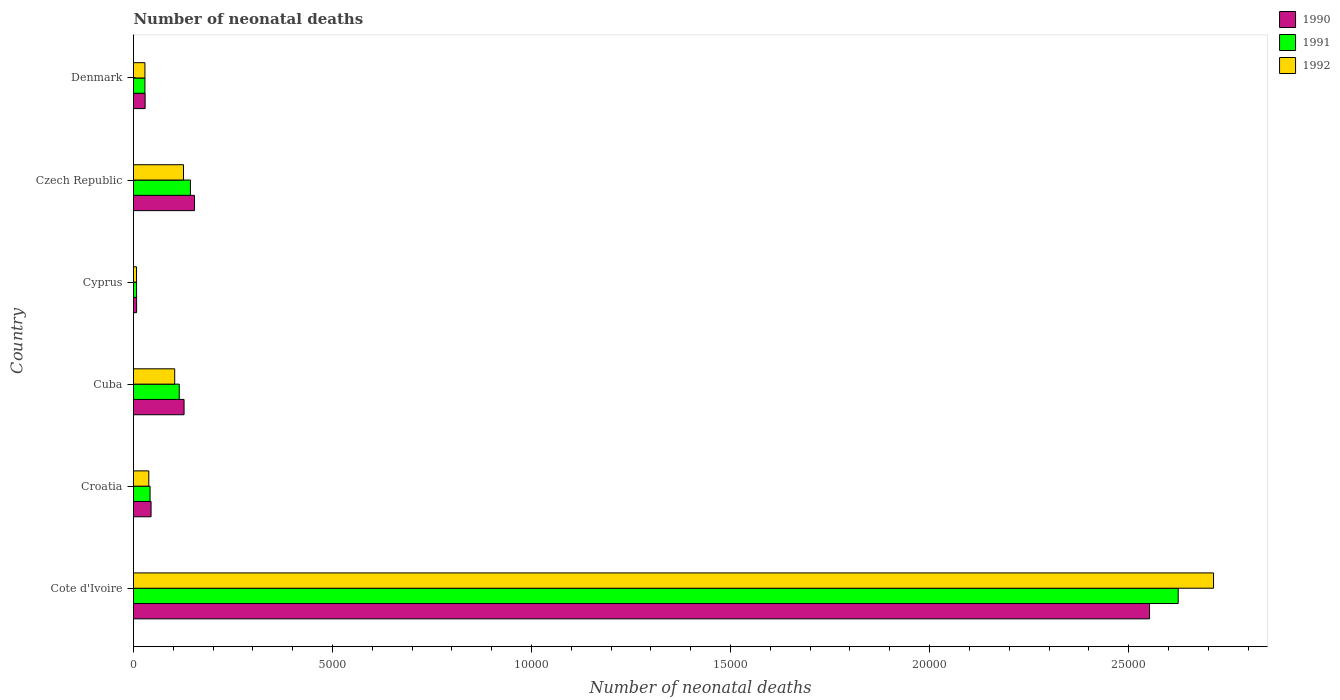How many different coloured bars are there?
Your answer should be very brief. 3. How many groups of bars are there?
Offer a very short reply. 6. How many bars are there on the 6th tick from the top?
Your answer should be very brief. 3. What is the label of the 6th group of bars from the top?
Provide a succinct answer. Cote d'Ivoire. In how many cases, is the number of bars for a given country not equal to the number of legend labels?
Ensure brevity in your answer.  0. What is the number of neonatal deaths in in 1990 in Croatia?
Give a very brief answer. 441. Across all countries, what is the maximum number of neonatal deaths in in 1990?
Make the answer very short. 2.55e+04. Across all countries, what is the minimum number of neonatal deaths in in 1992?
Keep it short and to the point. 76. In which country was the number of neonatal deaths in in 1990 maximum?
Offer a terse response. Cote d'Ivoire. In which country was the number of neonatal deaths in in 1990 minimum?
Provide a succinct answer. Cyprus. What is the total number of neonatal deaths in in 1991 in the graph?
Provide a short and direct response. 2.96e+04. What is the difference between the number of neonatal deaths in in 1991 in Cote d'Ivoire and that in Croatia?
Make the answer very short. 2.58e+04. What is the difference between the number of neonatal deaths in in 1990 in Denmark and the number of neonatal deaths in in 1991 in Czech Republic?
Ensure brevity in your answer.  -1138. What is the average number of neonatal deaths in in 1990 per country?
Your answer should be compact. 4856.67. What is the difference between the number of neonatal deaths in in 1992 and number of neonatal deaths in in 1991 in Cote d'Ivoire?
Your response must be concise. 888. In how many countries, is the number of neonatal deaths in in 1992 greater than 25000 ?
Your answer should be compact. 1. What is the ratio of the number of neonatal deaths in in 1990 in Cote d'Ivoire to that in Czech Republic?
Keep it short and to the point. 16.65. Is the difference between the number of neonatal deaths in in 1992 in Cote d'Ivoire and Cyprus greater than the difference between the number of neonatal deaths in in 1991 in Cote d'Ivoire and Cyprus?
Ensure brevity in your answer.  Yes. What is the difference between the highest and the second highest number of neonatal deaths in in 1992?
Give a very brief answer. 2.59e+04. What is the difference between the highest and the lowest number of neonatal deaths in in 1991?
Your response must be concise. 2.62e+04. In how many countries, is the number of neonatal deaths in in 1990 greater than the average number of neonatal deaths in in 1990 taken over all countries?
Provide a succinct answer. 1. Is the sum of the number of neonatal deaths in in 1990 in Croatia and Denmark greater than the maximum number of neonatal deaths in in 1992 across all countries?
Provide a succinct answer. No. How many bars are there?
Give a very brief answer. 18. How many countries are there in the graph?
Offer a terse response. 6. Where does the legend appear in the graph?
Your answer should be very brief. Top right. How many legend labels are there?
Provide a succinct answer. 3. What is the title of the graph?
Offer a very short reply. Number of neonatal deaths. What is the label or title of the X-axis?
Your response must be concise. Number of neonatal deaths. What is the Number of neonatal deaths of 1990 in Cote d'Ivoire?
Provide a short and direct response. 2.55e+04. What is the Number of neonatal deaths of 1991 in Cote d'Ivoire?
Give a very brief answer. 2.62e+04. What is the Number of neonatal deaths in 1992 in Cote d'Ivoire?
Your answer should be very brief. 2.71e+04. What is the Number of neonatal deaths of 1990 in Croatia?
Offer a terse response. 441. What is the Number of neonatal deaths of 1991 in Croatia?
Ensure brevity in your answer.  416. What is the Number of neonatal deaths in 1992 in Croatia?
Keep it short and to the point. 384. What is the Number of neonatal deaths in 1990 in Cuba?
Keep it short and to the point. 1270. What is the Number of neonatal deaths in 1991 in Cuba?
Make the answer very short. 1149. What is the Number of neonatal deaths of 1992 in Cuba?
Make the answer very short. 1035. What is the Number of neonatal deaths in 1992 in Cyprus?
Your answer should be very brief. 76. What is the Number of neonatal deaths in 1990 in Czech Republic?
Give a very brief answer. 1533. What is the Number of neonatal deaths of 1991 in Czech Republic?
Make the answer very short. 1430. What is the Number of neonatal deaths of 1992 in Czech Republic?
Provide a succinct answer. 1256. What is the Number of neonatal deaths in 1990 in Denmark?
Your response must be concise. 292. What is the Number of neonatal deaths in 1991 in Denmark?
Ensure brevity in your answer.  287. What is the Number of neonatal deaths in 1992 in Denmark?
Make the answer very short. 287. Across all countries, what is the maximum Number of neonatal deaths of 1990?
Your response must be concise. 2.55e+04. Across all countries, what is the maximum Number of neonatal deaths of 1991?
Your answer should be very brief. 2.62e+04. Across all countries, what is the maximum Number of neonatal deaths of 1992?
Provide a short and direct response. 2.71e+04. Across all countries, what is the minimum Number of neonatal deaths of 1991?
Keep it short and to the point. 77. What is the total Number of neonatal deaths in 1990 in the graph?
Offer a terse response. 2.91e+04. What is the total Number of neonatal deaths of 1991 in the graph?
Provide a short and direct response. 2.96e+04. What is the total Number of neonatal deaths in 1992 in the graph?
Your answer should be very brief. 3.02e+04. What is the difference between the Number of neonatal deaths of 1990 in Cote d'Ivoire and that in Croatia?
Keep it short and to the point. 2.51e+04. What is the difference between the Number of neonatal deaths of 1991 in Cote d'Ivoire and that in Croatia?
Your response must be concise. 2.58e+04. What is the difference between the Number of neonatal deaths of 1992 in Cote d'Ivoire and that in Croatia?
Ensure brevity in your answer.  2.68e+04. What is the difference between the Number of neonatal deaths in 1990 in Cote d'Ivoire and that in Cuba?
Keep it short and to the point. 2.43e+04. What is the difference between the Number of neonatal deaths in 1991 in Cote d'Ivoire and that in Cuba?
Make the answer very short. 2.51e+04. What is the difference between the Number of neonatal deaths in 1992 in Cote d'Ivoire and that in Cuba?
Ensure brevity in your answer.  2.61e+04. What is the difference between the Number of neonatal deaths in 1990 in Cote d'Ivoire and that in Cyprus?
Provide a short and direct response. 2.54e+04. What is the difference between the Number of neonatal deaths in 1991 in Cote d'Ivoire and that in Cyprus?
Keep it short and to the point. 2.62e+04. What is the difference between the Number of neonatal deaths of 1992 in Cote d'Ivoire and that in Cyprus?
Offer a very short reply. 2.71e+04. What is the difference between the Number of neonatal deaths of 1990 in Cote d'Ivoire and that in Czech Republic?
Ensure brevity in your answer.  2.40e+04. What is the difference between the Number of neonatal deaths of 1991 in Cote d'Ivoire and that in Czech Republic?
Give a very brief answer. 2.48e+04. What is the difference between the Number of neonatal deaths of 1992 in Cote d'Ivoire and that in Czech Republic?
Provide a short and direct response. 2.59e+04. What is the difference between the Number of neonatal deaths of 1990 in Cote d'Ivoire and that in Denmark?
Make the answer very short. 2.52e+04. What is the difference between the Number of neonatal deaths in 1991 in Cote d'Ivoire and that in Denmark?
Keep it short and to the point. 2.60e+04. What is the difference between the Number of neonatal deaths in 1992 in Cote d'Ivoire and that in Denmark?
Offer a terse response. 2.68e+04. What is the difference between the Number of neonatal deaths in 1990 in Croatia and that in Cuba?
Keep it short and to the point. -829. What is the difference between the Number of neonatal deaths of 1991 in Croatia and that in Cuba?
Keep it short and to the point. -733. What is the difference between the Number of neonatal deaths in 1992 in Croatia and that in Cuba?
Offer a terse response. -651. What is the difference between the Number of neonatal deaths of 1990 in Croatia and that in Cyprus?
Provide a short and direct response. 363. What is the difference between the Number of neonatal deaths of 1991 in Croatia and that in Cyprus?
Your response must be concise. 339. What is the difference between the Number of neonatal deaths in 1992 in Croatia and that in Cyprus?
Your answer should be very brief. 308. What is the difference between the Number of neonatal deaths in 1990 in Croatia and that in Czech Republic?
Ensure brevity in your answer.  -1092. What is the difference between the Number of neonatal deaths in 1991 in Croatia and that in Czech Republic?
Provide a short and direct response. -1014. What is the difference between the Number of neonatal deaths in 1992 in Croatia and that in Czech Republic?
Give a very brief answer. -872. What is the difference between the Number of neonatal deaths in 1990 in Croatia and that in Denmark?
Offer a very short reply. 149. What is the difference between the Number of neonatal deaths of 1991 in Croatia and that in Denmark?
Provide a short and direct response. 129. What is the difference between the Number of neonatal deaths of 1992 in Croatia and that in Denmark?
Offer a very short reply. 97. What is the difference between the Number of neonatal deaths in 1990 in Cuba and that in Cyprus?
Your answer should be very brief. 1192. What is the difference between the Number of neonatal deaths of 1991 in Cuba and that in Cyprus?
Ensure brevity in your answer.  1072. What is the difference between the Number of neonatal deaths of 1992 in Cuba and that in Cyprus?
Your response must be concise. 959. What is the difference between the Number of neonatal deaths in 1990 in Cuba and that in Czech Republic?
Your answer should be compact. -263. What is the difference between the Number of neonatal deaths in 1991 in Cuba and that in Czech Republic?
Provide a succinct answer. -281. What is the difference between the Number of neonatal deaths of 1992 in Cuba and that in Czech Republic?
Give a very brief answer. -221. What is the difference between the Number of neonatal deaths of 1990 in Cuba and that in Denmark?
Your answer should be very brief. 978. What is the difference between the Number of neonatal deaths of 1991 in Cuba and that in Denmark?
Your answer should be very brief. 862. What is the difference between the Number of neonatal deaths of 1992 in Cuba and that in Denmark?
Provide a short and direct response. 748. What is the difference between the Number of neonatal deaths of 1990 in Cyprus and that in Czech Republic?
Provide a succinct answer. -1455. What is the difference between the Number of neonatal deaths of 1991 in Cyprus and that in Czech Republic?
Your response must be concise. -1353. What is the difference between the Number of neonatal deaths of 1992 in Cyprus and that in Czech Republic?
Give a very brief answer. -1180. What is the difference between the Number of neonatal deaths of 1990 in Cyprus and that in Denmark?
Offer a terse response. -214. What is the difference between the Number of neonatal deaths of 1991 in Cyprus and that in Denmark?
Make the answer very short. -210. What is the difference between the Number of neonatal deaths in 1992 in Cyprus and that in Denmark?
Provide a short and direct response. -211. What is the difference between the Number of neonatal deaths of 1990 in Czech Republic and that in Denmark?
Your answer should be very brief. 1241. What is the difference between the Number of neonatal deaths of 1991 in Czech Republic and that in Denmark?
Provide a short and direct response. 1143. What is the difference between the Number of neonatal deaths in 1992 in Czech Republic and that in Denmark?
Keep it short and to the point. 969. What is the difference between the Number of neonatal deaths in 1990 in Cote d'Ivoire and the Number of neonatal deaths in 1991 in Croatia?
Make the answer very short. 2.51e+04. What is the difference between the Number of neonatal deaths of 1990 in Cote d'Ivoire and the Number of neonatal deaths of 1992 in Croatia?
Offer a very short reply. 2.51e+04. What is the difference between the Number of neonatal deaths of 1991 in Cote d'Ivoire and the Number of neonatal deaths of 1992 in Croatia?
Provide a succinct answer. 2.59e+04. What is the difference between the Number of neonatal deaths of 1990 in Cote d'Ivoire and the Number of neonatal deaths of 1991 in Cuba?
Offer a terse response. 2.44e+04. What is the difference between the Number of neonatal deaths in 1990 in Cote d'Ivoire and the Number of neonatal deaths in 1992 in Cuba?
Your answer should be very brief. 2.45e+04. What is the difference between the Number of neonatal deaths of 1991 in Cote d'Ivoire and the Number of neonatal deaths of 1992 in Cuba?
Keep it short and to the point. 2.52e+04. What is the difference between the Number of neonatal deaths of 1990 in Cote d'Ivoire and the Number of neonatal deaths of 1991 in Cyprus?
Provide a succinct answer. 2.54e+04. What is the difference between the Number of neonatal deaths in 1990 in Cote d'Ivoire and the Number of neonatal deaths in 1992 in Cyprus?
Your answer should be very brief. 2.54e+04. What is the difference between the Number of neonatal deaths in 1991 in Cote d'Ivoire and the Number of neonatal deaths in 1992 in Cyprus?
Your answer should be compact. 2.62e+04. What is the difference between the Number of neonatal deaths of 1990 in Cote d'Ivoire and the Number of neonatal deaths of 1991 in Czech Republic?
Your response must be concise. 2.41e+04. What is the difference between the Number of neonatal deaths of 1990 in Cote d'Ivoire and the Number of neonatal deaths of 1992 in Czech Republic?
Your response must be concise. 2.43e+04. What is the difference between the Number of neonatal deaths of 1991 in Cote d'Ivoire and the Number of neonatal deaths of 1992 in Czech Republic?
Keep it short and to the point. 2.50e+04. What is the difference between the Number of neonatal deaths of 1990 in Cote d'Ivoire and the Number of neonatal deaths of 1991 in Denmark?
Make the answer very short. 2.52e+04. What is the difference between the Number of neonatal deaths in 1990 in Cote d'Ivoire and the Number of neonatal deaths in 1992 in Denmark?
Make the answer very short. 2.52e+04. What is the difference between the Number of neonatal deaths in 1991 in Cote d'Ivoire and the Number of neonatal deaths in 1992 in Denmark?
Your answer should be very brief. 2.60e+04. What is the difference between the Number of neonatal deaths in 1990 in Croatia and the Number of neonatal deaths in 1991 in Cuba?
Provide a short and direct response. -708. What is the difference between the Number of neonatal deaths in 1990 in Croatia and the Number of neonatal deaths in 1992 in Cuba?
Give a very brief answer. -594. What is the difference between the Number of neonatal deaths in 1991 in Croatia and the Number of neonatal deaths in 1992 in Cuba?
Keep it short and to the point. -619. What is the difference between the Number of neonatal deaths in 1990 in Croatia and the Number of neonatal deaths in 1991 in Cyprus?
Provide a short and direct response. 364. What is the difference between the Number of neonatal deaths in 1990 in Croatia and the Number of neonatal deaths in 1992 in Cyprus?
Provide a succinct answer. 365. What is the difference between the Number of neonatal deaths in 1991 in Croatia and the Number of neonatal deaths in 1992 in Cyprus?
Provide a short and direct response. 340. What is the difference between the Number of neonatal deaths of 1990 in Croatia and the Number of neonatal deaths of 1991 in Czech Republic?
Ensure brevity in your answer.  -989. What is the difference between the Number of neonatal deaths of 1990 in Croatia and the Number of neonatal deaths of 1992 in Czech Republic?
Offer a very short reply. -815. What is the difference between the Number of neonatal deaths of 1991 in Croatia and the Number of neonatal deaths of 1992 in Czech Republic?
Offer a very short reply. -840. What is the difference between the Number of neonatal deaths in 1990 in Croatia and the Number of neonatal deaths in 1991 in Denmark?
Provide a succinct answer. 154. What is the difference between the Number of neonatal deaths in 1990 in Croatia and the Number of neonatal deaths in 1992 in Denmark?
Offer a terse response. 154. What is the difference between the Number of neonatal deaths of 1991 in Croatia and the Number of neonatal deaths of 1992 in Denmark?
Provide a succinct answer. 129. What is the difference between the Number of neonatal deaths of 1990 in Cuba and the Number of neonatal deaths of 1991 in Cyprus?
Offer a very short reply. 1193. What is the difference between the Number of neonatal deaths of 1990 in Cuba and the Number of neonatal deaths of 1992 in Cyprus?
Provide a short and direct response. 1194. What is the difference between the Number of neonatal deaths of 1991 in Cuba and the Number of neonatal deaths of 1992 in Cyprus?
Provide a succinct answer. 1073. What is the difference between the Number of neonatal deaths in 1990 in Cuba and the Number of neonatal deaths in 1991 in Czech Republic?
Give a very brief answer. -160. What is the difference between the Number of neonatal deaths in 1991 in Cuba and the Number of neonatal deaths in 1992 in Czech Republic?
Make the answer very short. -107. What is the difference between the Number of neonatal deaths in 1990 in Cuba and the Number of neonatal deaths in 1991 in Denmark?
Your answer should be compact. 983. What is the difference between the Number of neonatal deaths in 1990 in Cuba and the Number of neonatal deaths in 1992 in Denmark?
Make the answer very short. 983. What is the difference between the Number of neonatal deaths of 1991 in Cuba and the Number of neonatal deaths of 1992 in Denmark?
Provide a short and direct response. 862. What is the difference between the Number of neonatal deaths of 1990 in Cyprus and the Number of neonatal deaths of 1991 in Czech Republic?
Offer a very short reply. -1352. What is the difference between the Number of neonatal deaths in 1990 in Cyprus and the Number of neonatal deaths in 1992 in Czech Republic?
Provide a succinct answer. -1178. What is the difference between the Number of neonatal deaths in 1991 in Cyprus and the Number of neonatal deaths in 1992 in Czech Republic?
Make the answer very short. -1179. What is the difference between the Number of neonatal deaths of 1990 in Cyprus and the Number of neonatal deaths of 1991 in Denmark?
Make the answer very short. -209. What is the difference between the Number of neonatal deaths in 1990 in Cyprus and the Number of neonatal deaths in 1992 in Denmark?
Your answer should be compact. -209. What is the difference between the Number of neonatal deaths of 1991 in Cyprus and the Number of neonatal deaths of 1992 in Denmark?
Offer a terse response. -210. What is the difference between the Number of neonatal deaths of 1990 in Czech Republic and the Number of neonatal deaths of 1991 in Denmark?
Make the answer very short. 1246. What is the difference between the Number of neonatal deaths in 1990 in Czech Republic and the Number of neonatal deaths in 1992 in Denmark?
Provide a succinct answer. 1246. What is the difference between the Number of neonatal deaths in 1991 in Czech Republic and the Number of neonatal deaths in 1992 in Denmark?
Provide a succinct answer. 1143. What is the average Number of neonatal deaths of 1990 per country?
Offer a terse response. 4856.67. What is the average Number of neonatal deaths in 1991 per country?
Offer a terse response. 4934.17. What is the average Number of neonatal deaths in 1992 per country?
Your response must be concise. 5028.67. What is the difference between the Number of neonatal deaths of 1990 and Number of neonatal deaths of 1991 in Cote d'Ivoire?
Your answer should be very brief. -720. What is the difference between the Number of neonatal deaths in 1990 and Number of neonatal deaths in 1992 in Cote d'Ivoire?
Make the answer very short. -1608. What is the difference between the Number of neonatal deaths of 1991 and Number of neonatal deaths of 1992 in Cote d'Ivoire?
Give a very brief answer. -888. What is the difference between the Number of neonatal deaths in 1991 and Number of neonatal deaths in 1992 in Croatia?
Your answer should be compact. 32. What is the difference between the Number of neonatal deaths of 1990 and Number of neonatal deaths of 1991 in Cuba?
Ensure brevity in your answer.  121. What is the difference between the Number of neonatal deaths of 1990 and Number of neonatal deaths of 1992 in Cuba?
Offer a terse response. 235. What is the difference between the Number of neonatal deaths of 1991 and Number of neonatal deaths of 1992 in Cuba?
Provide a short and direct response. 114. What is the difference between the Number of neonatal deaths of 1990 and Number of neonatal deaths of 1991 in Czech Republic?
Provide a succinct answer. 103. What is the difference between the Number of neonatal deaths in 1990 and Number of neonatal deaths in 1992 in Czech Republic?
Your answer should be compact. 277. What is the difference between the Number of neonatal deaths of 1991 and Number of neonatal deaths of 1992 in Czech Republic?
Provide a succinct answer. 174. What is the difference between the Number of neonatal deaths in 1990 and Number of neonatal deaths in 1992 in Denmark?
Your answer should be compact. 5. What is the ratio of the Number of neonatal deaths in 1990 in Cote d'Ivoire to that in Croatia?
Keep it short and to the point. 57.88. What is the ratio of the Number of neonatal deaths in 1991 in Cote d'Ivoire to that in Croatia?
Give a very brief answer. 63.09. What is the ratio of the Number of neonatal deaths of 1992 in Cote d'Ivoire to that in Croatia?
Your answer should be compact. 70.66. What is the ratio of the Number of neonatal deaths in 1990 in Cote d'Ivoire to that in Cuba?
Provide a short and direct response. 20.1. What is the ratio of the Number of neonatal deaths in 1991 in Cote d'Ivoire to that in Cuba?
Your answer should be very brief. 22.84. What is the ratio of the Number of neonatal deaths of 1992 in Cote d'Ivoire to that in Cuba?
Offer a very short reply. 26.22. What is the ratio of the Number of neonatal deaths in 1990 in Cote d'Ivoire to that in Cyprus?
Provide a short and direct response. 327.26. What is the ratio of the Number of neonatal deaths in 1991 in Cote d'Ivoire to that in Cyprus?
Keep it short and to the point. 340.86. What is the ratio of the Number of neonatal deaths in 1992 in Cote d'Ivoire to that in Cyprus?
Provide a succinct answer. 357.03. What is the ratio of the Number of neonatal deaths of 1990 in Cote d'Ivoire to that in Czech Republic?
Your answer should be compact. 16.65. What is the ratio of the Number of neonatal deaths of 1991 in Cote d'Ivoire to that in Czech Republic?
Your response must be concise. 18.35. What is the ratio of the Number of neonatal deaths in 1992 in Cote d'Ivoire to that in Czech Republic?
Offer a terse response. 21.6. What is the ratio of the Number of neonatal deaths of 1990 in Cote d'Ivoire to that in Denmark?
Provide a short and direct response. 87.42. What is the ratio of the Number of neonatal deaths in 1991 in Cote d'Ivoire to that in Denmark?
Your answer should be compact. 91.45. What is the ratio of the Number of neonatal deaths in 1992 in Cote d'Ivoire to that in Denmark?
Your response must be concise. 94.54. What is the ratio of the Number of neonatal deaths of 1990 in Croatia to that in Cuba?
Your response must be concise. 0.35. What is the ratio of the Number of neonatal deaths in 1991 in Croatia to that in Cuba?
Make the answer very short. 0.36. What is the ratio of the Number of neonatal deaths of 1992 in Croatia to that in Cuba?
Provide a short and direct response. 0.37. What is the ratio of the Number of neonatal deaths of 1990 in Croatia to that in Cyprus?
Provide a succinct answer. 5.65. What is the ratio of the Number of neonatal deaths of 1991 in Croatia to that in Cyprus?
Ensure brevity in your answer.  5.4. What is the ratio of the Number of neonatal deaths in 1992 in Croatia to that in Cyprus?
Provide a succinct answer. 5.05. What is the ratio of the Number of neonatal deaths of 1990 in Croatia to that in Czech Republic?
Your answer should be very brief. 0.29. What is the ratio of the Number of neonatal deaths in 1991 in Croatia to that in Czech Republic?
Make the answer very short. 0.29. What is the ratio of the Number of neonatal deaths of 1992 in Croatia to that in Czech Republic?
Make the answer very short. 0.31. What is the ratio of the Number of neonatal deaths in 1990 in Croatia to that in Denmark?
Offer a terse response. 1.51. What is the ratio of the Number of neonatal deaths in 1991 in Croatia to that in Denmark?
Offer a terse response. 1.45. What is the ratio of the Number of neonatal deaths in 1992 in Croatia to that in Denmark?
Make the answer very short. 1.34. What is the ratio of the Number of neonatal deaths of 1990 in Cuba to that in Cyprus?
Make the answer very short. 16.28. What is the ratio of the Number of neonatal deaths in 1991 in Cuba to that in Cyprus?
Your answer should be compact. 14.92. What is the ratio of the Number of neonatal deaths of 1992 in Cuba to that in Cyprus?
Keep it short and to the point. 13.62. What is the ratio of the Number of neonatal deaths of 1990 in Cuba to that in Czech Republic?
Give a very brief answer. 0.83. What is the ratio of the Number of neonatal deaths in 1991 in Cuba to that in Czech Republic?
Provide a short and direct response. 0.8. What is the ratio of the Number of neonatal deaths of 1992 in Cuba to that in Czech Republic?
Ensure brevity in your answer.  0.82. What is the ratio of the Number of neonatal deaths of 1990 in Cuba to that in Denmark?
Your answer should be compact. 4.35. What is the ratio of the Number of neonatal deaths of 1991 in Cuba to that in Denmark?
Ensure brevity in your answer.  4. What is the ratio of the Number of neonatal deaths of 1992 in Cuba to that in Denmark?
Provide a short and direct response. 3.61. What is the ratio of the Number of neonatal deaths of 1990 in Cyprus to that in Czech Republic?
Give a very brief answer. 0.05. What is the ratio of the Number of neonatal deaths in 1991 in Cyprus to that in Czech Republic?
Provide a short and direct response. 0.05. What is the ratio of the Number of neonatal deaths in 1992 in Cyprus to that in Czech Republic?
Make the answer very short. 0.06. What is the ratio of the Number of neonatal deaths of 1990 in Cyprus to that in Denmark?
Offer a very short reply. 0.27. What is the ratio of the Number of neonatal deaths of 1991 in Cyprus to that in Denmark?
Offer a very short reply. 0.27. What is the ratio of the Number of neonatal deaths of 1992 in Cyprus to that in Denmark?
Keep it short and to the point. 0.26. What is the ratio of the Number of neonatal deaths of 1990 in Czech Republic to that in Denmark?
Offer a terse response. 5.25. What is the ratio of the Number of neonatal deaths of 1991 in Czech Republic to that in Denmark?
Make the answer very short. 4.98. What is the ratio of the Number of neonatal deaths in 1992 in Czech Republic to that in Denmark?
Provide a succinct answer. 4.38. What is the difference between the highest and the second highest Number of neonatal deaths of 1990?
Keep it short and to the point. 2.40e+04. What is the difference between the highest and the second highest Number of neonatal deaths in 1991?
Your response must be concise. 2.48e+04. What is the difference between the highest and the second highest Number of neonatal deaths in 1992?
Your answer should be compact. 2.59e+04. What is the difference between the highest and the lowest Number of neonatal deaths in 1990?
Offer a terse response. 2.54e+04. What is the difference between the highest and the lowest Number of neonatal deaths of 1991?
Offer a very short reply. 2.62e+04. What is the difference between the highest and the lowest Number of neonatal deaths of 1992?
Offer a terse response. 2.71e+04. 